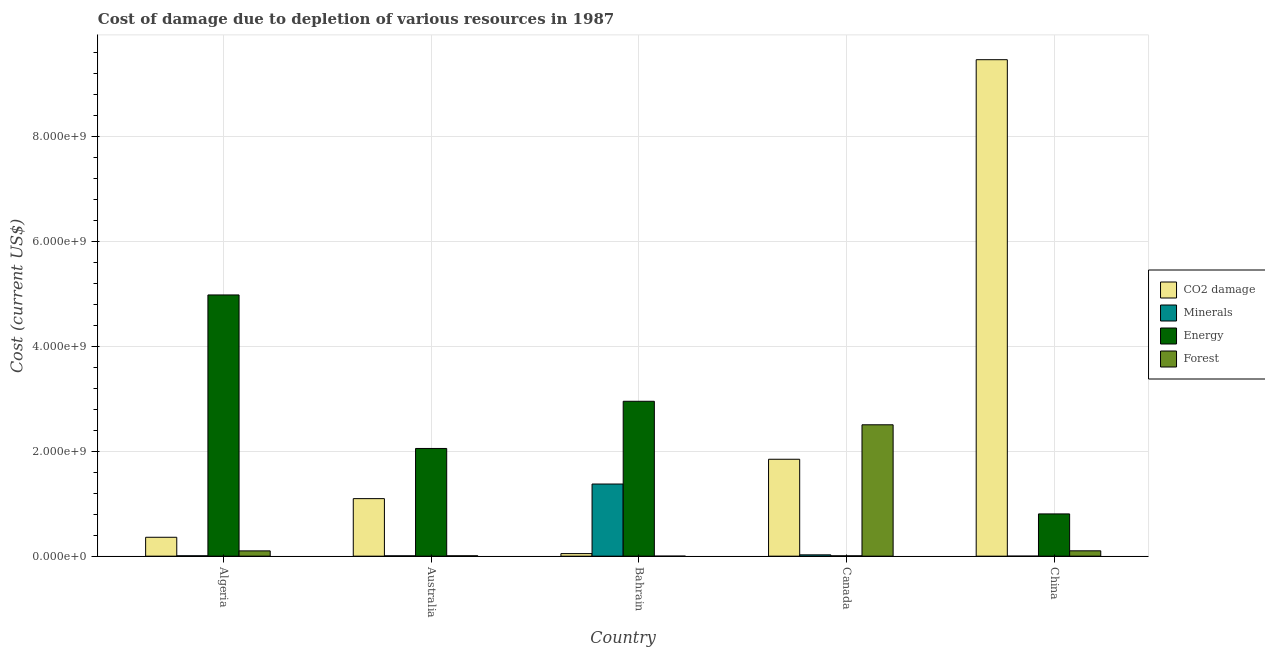Are the number of bars per tick equal to the number of legend labels?
Make the answer very short. Yes. How many bars are there on the 5th tick from the left?
Your answer should be very brief. 4. How many bars are there on the 1st tick from the right?
Give a very brief answer. 4. In how many cases, is the number of bars for a given country not equal to the number of legend labels?
Offer a very short reply. 0. What is the cost of damage due to depletion of coal in China?
Keep it short and to the point. 9.46e+09. Across all countries, what is the maximum cost of damage due to depletion of coal?
Your answer should be compact. 9.46e+09. Across all countries, what is the minimum cost of damage due to depletion of forests?
Ensure brevity in your answer.  1.92e+05. In which country was the cost of damage due to depletion of minerals minimum?
Your answer should be very brief. China. What is the total cost of damage due to depletion of minerals in the graph?
Provide a succinct answer. 1.41e+09. What is the difference between the cost of damage due to depletion of energy in Bahrain and that in Canada?
Provide a succinct answer. 2.94e+09. What is the difference between the cost of damage due to depletion of coal in Australia and the cost of damage due to depletion of forests in Canada?
Give a very brief answer. -1.41e+09. What is the average cost of damage due to depletion of energy per country?
Your answer should be compact. 2.16e+09. What is the difference between the cost of damage due to depletion of forests and cost of damage due to depletion of coal in Australia?
Your response must be concise. -1.09e+09. What is the ratio of the cost of damage due to depletion of minerals in Algeria to that in China?
Your response must be concise. 401.95. Is the difference between the cost of damage due to depletion of forests in Australia and Canada greater than the difference between the cost of damage due to depletion of coal in Australia and Canada?
Provide a short and direct response. No. What is the difference between the highest and the second highest cost of damage due to depletion of minerals?
Your response must be concise. 1.35e+09. What is the difference between the highest and the lowest cost of damage due to depletion of forests?
Make the answer very short. 2.50e+09. In how many countries, is the cost of damage due to depletion of energy greater than the average cost of damage due to depletion of energy taken over all countries?
Ensure brevity in your answer.  2. What does the 1st bar from the left in Australia represents?
Offer a very short reply. CO2 damage. What does the 2nd bar from the right in Canada represents?
Your response must be concise. Energy. How many bars are there?
Make the answer very short. 20. Are all the bars in the graph horizontal?
Ensure brevity in your answer.  No. How many countries are there in the graph?
Ensure brevity in your answer.  5. What is the difference between two consecutive major ticks on the Y-axis?
Offer a very short reply. 2.00e+09. How many legend labels are there?
Give a very brief answer. 4. What is the title of the graph?
Make the answer very short. Cost of damage due to depletion of various resources in 1987 . Does "Regional development banks" appear as one of the legend labels in the graph?
Your response must be concise. No. What is the label or title of the X-axis?
Offer a terse response. Country. What is the label or title of the Y-axis?
Provide a short and direct response. Cost (current US$). What is the Cost (current US$) of CO2 damage in Algeria?
Offer a terse response. 3.60e+08. What is the Cost (current US$) in Minerals in Algeria?
Provide a short and direct response. 7.39e+06. What is the Cost (current US$) in Energy in Algeria?
Your response must be concise. 4.97e+09. What is the Cost (current US$) in Forest in Algeria?
Offer a terse response. 1.01e+08. What is the Cost (current US$) in CO2 damage in Australia?
Make the answer very short. 1.10e+09. What is the Cost (current US$) in Minerals in Australia?
Provide a succinct answer. 6.31e+06. What is the Cost (current US$) of Energy in Australia?
Keep it short and to the point. 2.05e+09. What is the Cost (current US$) of Forest in Australia?
Offer a terse response. 7.12e+06. What is the Cost (current US$) in CO2 damage in Bahrain?
Keep it short and to the point. 4.89e+07. What is the Cost (current US$) of Minerals in Bahrain?
Give a very brief answer. 1.37e+09. What is the Cost (current US$) of Energy in Bahrain?
Your response must be concise. 2.95e+09. What is the Cost (current US$) in Forest in Bahrain?
Provide a succinct answer. 1.92e+05. What is the Cost (current US$) of CO2 damage in Canada?
Keep it short and to the point. 1.85e+09. What is the Cost (current US$) of Minerals in Canada?
Ensure brevity in your answer.  2.52e+07. What is the Cost (current US$) in Energy in Canada?
Your answer should be compact. 6.45e+06. What is the Cost (current US$) in Forest in Canada?
Make the answer very short. 2.50e+09. What is the Cost (current US$) in CO2 damage in China?
Offer a very short reply. 9.46e+09. What is the Cost (current US$) of Minerals in China?
Offer a very short reply. 1.84e+04. What is the Cost (current US$) in Energy in China?
Provide a succinct answer. 8.05e+08. What is the Cost (current US$) of Forest in China?
Give a very brief answer. 1.02e+08. Across all countries, what is the maximum Cost (current US$) of CO2 damage?
Make the answer very short. 9.46e+09. Across all countries, what is the maximum Cost (current US$) in Minerals?
Your answer should be compact. 1.37e+09. Across all countries, what is the maximum Cost (current US$) in Energy?
Ensure brevity in your answer.  4.97e+09. Across all countries, what is the maximum Cost (current US$) of Forest?
Offer a terse response. 2.50e+09. Across all countries, what is the minimum Cost (current US$) of CO2 damage?
Ensure brevity in your answer.  4.89e+07. Across all countries, what is the minimum Cost (current US$) of Minerals?
Your answer should be compact. 1.84e+04. Across all countries, what is the minimum Cost (current US$) in Energy?
Your response must be concise. 6.45e+06. Across all countries, what is the minimum Cost (current US$) in Forest?
Make the answer very short. 1.92e+05. What is the total Cost (current US$) in CO2 damage in the graph?
Make the answer very short. 1.28e+1. What is the total Cost (current US$) in Minerals in the graph?
Your response must be concise. 1.41e+09. What is the total Cost (current US$) of Energy in the graph?
Keep it short and to the point. 1.08e+1. What is the total Cost (current US$) in Forest in the graph?
Give a very brief answer. 2.71e+09. What is the difference between the Cost (current US$) in CO2 damage in Algeria and that in Australia?
Provide a short and direct response. -7.36e+08. What is the difference between the Cost (current US$) of Minerals in Algeria and that in Australia?
Your response must be concise. 1.08e+06. What is the difference between the Cost (current US$) of Energy in Algeria and that in Australia?
Offer a very short reply. 2.92e+09. What is the difference between the Cost (current US$) of Forest in Algeria and that in Australia?
Keep it short and to the point. 9.35e+07. What is the difference between the Cost (current US$) in CO2 damage in Algeria and that in Bahrain?
Make the answer very short. 3.11e+08. What is the difference between the Cost (current US$) of Minerals in Algeria and that in Bahrain?
Offer a terse response. -1.37e+09. What is the difference between the Cost (current US$) of Energy in Algeria and that in Bahrain?
Offer a terse response. 2.02e+09. What is the difference between the Cost (current US$) of Forest in Algeria and that in Bahrain?
Offer a terse response. 1.00e+08. What is the difference between the Cost (current US$) of CO2 damage in Algeria and that in Canada?
Offer a terse response. -1.49e+09. What is the difference between the Cost (current US$) in Minerals in Algeria and that in Canada?
Keep it short and to the point. -1.78e+07. What is the difference between the Cost (current US$) of Energy in Algeria and that in Canada?
Provide a short and direct response. 4.97e+09. What is the difference between the Cost (current US$) in Forest in Algeria and that in Canada?
Keep it short and to the point. -2.40e+09. What is the difference between the Cost (current US$) in CO2 damage in Algeria and that in China?
Provide a succinct answer. -9.10e+09. What is the difference between the Cost (current US$) of Minerals in Algeria and that in China?
Offer a terse response. 7.37e+06. What is the difference between the Cost (current US$) in Energy in Algeria and that in China?
Offer a terse response. 4.17e+09. What is the difference between the Cost (current US$) in Forest in Algeria and that in China?
Give a very brief answer. -1.20e+06. What is the difference between the Cost (current US$) in CO2 damage in Australia and that in Bahrain?
Provide a short and direct response. 1.05e+09. What is the difference between the Cost (current US$) in Minerals in Australia and that in Bahrain?
Your answer should be compact. -1.37e+09. What is the difference between the Cost (current US$) of Energy in Australia and that in Bahrain?
Your answer should be compact. -8.99e+08. What is the difference between the Cost (current US$) of Forest in Australia and that in Bahrain?
Your answer should be compact. 6.92e+06. What is the difference between the Cost (current US$) in CO2 damage in Australia and that in Canada?
Make the answer very short. -7.50e+08. What is the difference between the Cost (current US$) in Minerals in Australia and that in Canada?
Offer a terse response. -1.89e+07. What is the difference between the Cost (current US$) of Energy in Australia and that in Canada?
Your answer should be compact. 2.04e+09. What is the difference between the Cost (current US$) of Forest in Australia and that in Canada?
Ensure brevity in your answer.  -2.50e+09. What is the difference between the Cost (current US$) of CO2 damage in Australia and that in China?
Ensure brevity in your answer.  -8.36e+09. What is the difference between the Cost (current US$) of Minerals in Australia and that in China?
Your response must be concise. 6.29e+06. What is the difference between the Cost (current US$) in Energy in Australia and that in China?
Provide a succinct answer. 1.25e+09. What is the difference between the Cost (current US$) of Forest in Australia and that in China?
Give a very brief answer. -9.47e+07. What is the difference between the Cost (current US$) in CO2 damage in Bahrain and that in Canada?
Provide a succinct answer. -1.80e+09. What is the difference between the Cost (current US$) in Minerals in Bahrain and that in Canada?
Offer a terse response. 1.35e+09. What is the difference between the Cost (current US$) in Energy in Bahrain and that in Canada?
Give a very brief answer. 2.94e+09. What is the difference between the Cost (current US$) of Forest in Bahrain and that in Canada?
Make the answer very short. -2.50e+09. What is the difference between the Cost (current US$) of CO2 damage in Bahrain and that in China?
Offer a terse response. -9.41e+09. What is the difference between the Cost (current US$) in Minerals in Bahrain and that in China?
Your response must be concise. 1.37e+09. What is the difference between the Cost (current US$) of Energy in Bahrain and that in China?
Offer a terse response. 2.15e+09. What is the difference between the Cost (current US$) of Forest in Bahrain and that in China?
Provide a short and direct response. -1.02e+08. What is the difference between the Cost (current US$) of CO2 damage in Canada and that in China?
Your response must be concise. -7.61e+09. What is the difference between the Cost (current US$) in Minerals in Canada and that in China?
Keep it short and to the point. 2.51e+07. What is the difference between the Cost (current US$) of Energy in Canada and that in China?
Keep it short and to the point. -7.98e+08. What is the difference between the Cost (current US$) of Forest in Canada and that in China?
Keep it short and to the point. 2.40e+09. What is the difference between the Cost (current US$) of CO2 damage in Algeria and the Cost (current US$) of Minerals in Australia?
Provide a succinct answer. 3.54e+08. What is the difference between the Cost (current US$) of CO2 damage in Algeria and the Cost (current US$) of Energy in Australia?
Keep it short and to the point. -1.69e+09. What is the difference between the Cost (current US$) of CO2 damage in Algeria and the Cost (current US$) of Forest in Australia?
Offer a very short reply. 3.53e+08. What is the difference between the Cost (current US$) of Minerals in Algeria and the Cost (current US$) of Energy in Australia?
Give a very brief answer. -2.04e+09. What is the difference between the Cost (current US$) in Minerals in Algeria and the Cost (current US$) in Forest in Australia?
Keep it short and to the point. 2.70e+05. What is the difference between the Cost (current US$) of Energy in Algeria and the Cost (current US$) of Forest in Australia?
Your response must be concise. 4.97e+09. What is the difference between the Cost (current US$) of CO2 damage in Algeria and the Cost (current US$) of Minerals in Bahrain?
Provide a succinct answer. -1.01e+09. What is the difference between the Cost (current US$) of CO2 damage in Algeria and the Cost (current US$) of Energy in Bahrain?
Keep it short and to the point. -2.59e+09. What is the difference between the Cost (current US$) in CO2 damage in Algeria and the Cost (current US$) in Forest in Bahrain?
Your answer should be compact. 3.60e+08. What is the difference between the Cost (current US$) of Minerals in Algeria and the Cost (current US$) of Energy in Bahrain?
Offer a terse response. -2.94e+09. What is the difference between the Cost (current US$) of Minerals in Algeria and the Cost (current US$) of Forest in Bahrain?
Offer a terse response. 7.19e+06. What is the difference between the Cost (current US$) of Energy in Algeria and the Cost (current US$) of Forest in Bahrain?
Your response must be concise. 4.97e+09. What is the difference between the Cost (current US$) in CO2 damage in Algeria and the Cost (current US$) in Minerals in Canada?
Offer a terse response. 3.35e+08. What is the difference between the Cost (current US$) in CO2 damage in Algeria and the Cost (current US$) in Energy in Canada?
Give a very brief answer. 3.54e+08. What is the difference between the Cost (current US$) of CO2 damage in Algeria and the Cost (current US$) of Forest in Canada?
Your answer should be compact. -2.14e+09. What is the difference between the Cost (current US$) of Minerals in Algeria and the Cost (current US$) of Energy in Canada?
Your answer should be compact. 9.36e+05. What is the difference between the Cost (current US$) in Minerals in Algeria and the Cost (current US$) in Forest in Canada?
Offer a very short reply. -2.49e+09. What is the difference between the Cost (current US$) of Energy in Algeria and the Cost (current US$) of Forest in Canada?
Offer a terse response. 2.47e+09. What is the difference between the Cost (current US$) of CO2 damage in Algeria and the Cost (current US$) of Minerals in China?
Provide a short and direct response. 3.60e+08. What is the difference between the Cost (current US$) of CO2 damage in Algeria and the Cost (current US$) of Energy in China?
Offer a very short reply. -4.45e+08. What is the difference between the Cost (current US$) in CO2 damage in Algeria and the Cost (current US$) in Forest in China?
Make the answer very short. 2.58e+08. What is the difference between the Cost (current US$) of Minerals in Algeria and the Cost (current US$) of Energy in China?
Offer a very short reply. -7.97e+08. What is the difference between the Cost (current US$) of Minerals in Algeria and the Cost (current US$) of Forest in China?
Make the answer very short. -9.45e+07. What is the difference between the Cost (current US$) of Energy in Algeria and the Cost (current US$) of Forest in China?
Your answer should be very brief. 4.87e+09. What is the difference between the Cost (current US$) in CO2 damage in Australia and the Cost (current US$) in Minerals in Bahrain?
Keep it short and to the point. -2.78e+08. What is the difference between the Cost (current US$) of CO2 damage in Australia and the Cost (current US$) of Energy in Bahrain?
Your response must be concise. -1.85e+09. What is the difference between the Cost (current US$) in CO2 damage in Australia and the Cost (current US$) in Forest in Bahrain?
Provide a succinct answer. 1.10e+09. What is the difference between the Cost (current US$) in Minerals in Australia and the Cost (current US$) in Energy in Bahrain?
Provide a succinct answer. -2.94e+09. What is the difference between the Cost (current US$) in Minerals in Australia and the Cost (current US$) in Forest in Bahrain?
Offer a very short reply. 6.11e+06. What is the difference between the Cost (current US$) of Energy in Australia and the Cost (current US$) of Forest in Bahrain?
Provide a succinct answer. 2.05e+09. What is the difference between the Cost (current US$) of CO2 damage in Australia and the Cost (current US$) of Minerals in Canada?
Provide a succinct answer. 1.07e+09. What is the difference between the Cost (current US$) in CO2 damage in Australia and the Cost (current US$) in Energy in Canada?
Provide a succinct answer. 1.09e+09. What is the difference between the Cost (current US$) in CO2 damage in Australia and the Cost (current US$) in Forest in Canada?
Your answer should be compact. -1.41e+09. What is the difference between the Cost (current US$) of Minerals in Australia and the Cost (current US$) of Energy in Canada?
Your answer should be compact. -1.43e+05. What is the difference between the Cost (current US$) in Minerals in Australia and the Cost (current US$) in Forest in Canada?
Offer a terse response. -2.50e+09. What is the difference between the Cost (current US$) in Energy in Australia and the Cost (current US$) in Forest in Canada?
Offer a very short reply. -4.51e+08. What is the difference between the Cost (current US$) of CO2 damage in Australia and the Cost (current US$) of Minerals in China?
Give a very brief answer. 1.10e+09. What is the difference between the Cost (current US$) of CO2 damage in Australia and the Cost (current US$) of Energy in China?
Your answer should be very brief. 2.91e+08. What is the difference between the Cost (current US$) in CO2 damage in Australia and the Cost (current US$) in Forest in China?
Keep it short and to the point. 9.94e+08. What is the difference between the Cost (current US$) of Minerals in Australia and the Cost (current US$) of Energy in China?
Provide a succinct answer. -7.98e+08. What is the difference between the Cost (current US$) in Minerals in Australia and the Cost (current US$) in Forest in China?
Ensure brevity in your answer.  -9.56e+07. What is the difference between the Cost (current US$) of Energy in Australia and the Cost (current US$) of Forest in China?
Keep it short and to the point. 1.95e+09. What is the difference between the Cost (current US$) in CO2 damage in Bahrain and the Cost (current US$) in Minerals in Canada?
Provide a short and direct response. 2.37e+07. What is the difference between the Cost (current US$) in CO2 damage in Bahrain and the Cost (current US$) in Energy in Canada?
Your response must be concise. 4.25e+07. What is the difference between the Cost (current US$) in CO2 damage in Bahrain and the Cost (current US$) in Forest in Canada?
Ensure brevity in your answer.  -2.45e+09. What is the difference between the Cost (current US$) of Minerals in Bahrain and the Cost (current US$) of Energy in Canada?
Your response must be concise. 1.37e+09. What is the difference between the Cost (current US$) in Minerals in Bahrain and the Cost (current US$) in Forest in Canada?
Offer a very short reply. -1.13e+09. What is the difference between the Cost (current US$) of Energy in Bahrain and the Cost (current US$) of Forest in Canada?
Your response must be concise. 4.48e+08. What is the difference between the Cost (current US$) in CO2 damage in Bahrain and the Cost (current US$) in Minerals in China?
Offer a very short reply. 4.89e+07. What is the difference between the Cost (current US$) of CO2 damage in Bahrain and the Cost (current US$) of Energy in China?
Your answer should be compact. -7.56e+08. What is the difference between the Cost (current US$) of CO2 damage in Bahrain and the Cost (current US$) of Forest in China?
Your answer should be very brief. -5.29e+07. What is the difference between the Cost (current US$) of Minerals in Bahrain and the Cost (current US$) of Energy in China?
Ensure brevity in your answer.  5.69e+08. What is the difference between the Cost (current US$) of Minerals in Bahrain and the Cost (current US$) of Forest in China?
Your answer should be compact. 1.27e+09. What is the difference between the Cost (current US$) of Energy in Bahrain and the Cost (current US$) of Forest in China?
Offer a terse response. 2.85e+09. What is the difference between the Cost (current US$) in CO2 damage in Canada and the Cost (current US$) in Minerals in China?
Your answer should be compact. 1.85e+09. What is the difference between the Cost (current US$) in CO2 damage in Canada and the Cost (current US$) in Energy in China?
Keep it short and to the point. 1.04e+09. What is the difference between the Cost (current US$) in CO2 damage in Canada and the Cost (current US$) in Forest in China?
Offer a terse response. 1.74e+09. What is the difference between the Cost (current US$) in Minerals in Canada and the Cost (current US$) in Energy in China?
Give a very brief answer. -7.80e+08. What is the difference between the Cost (current US$) of Minerals in Canada and the Cost (current US$) of Forest in China?
Your response must be concise. -7.67e+07. What is the difference between the Cost (current US$) of Energy in Canada and the Cost (current US$) of Forest in China?
Provide a short and direct response. -9.54e+07. What is the average Cost (current US$) of CO2 damage per country?
Ensure brevity in your answer.  2.56e+09. What is the average Cost (current US$) in Minerals per country?
Provide a short and direct response. 2.83e+08. What is the average Cost (current US$) of Energy per country?
Give a very brief answer. 2.16e+09. What is the average Cost (current US$) in Forest per country?
Your answer should be compact. 5.42e+08. What is the difference between the Cost (current US$) of CO2 damage and Cost (current US$) of Minerals in Algeria?
Offer a very short reply. 3.53e+08. What is the difference between the Cost (current US$) in CO2 damage and Cost (current US$) in Energy in Algeria?
Your answer should be very brief. -4.62e+09. What is the difference between the Cost (current US$) of CO2 damage and Cost (current US$) of Forest in Algeria?
Offer a very short reply. 2.59e+08. What is the difference between the Cost (current US$) in Minerals and Cost (current US$) in Energy in Algeria?
Your answer should be very brief. -4.97e+09. What is the difference between the Cost (current US$) of Minerals and Cost (current US$) of Forest in Algeria?
Keep it short and to the point. -9.33e+07. What is the difference between the Cost (current US$) in Energy and Cost (current US$) in Forest in Algeria?
Give a very brief answer. 4.87e+09. What is the difference between the Cost (current US$) in CO2 damage and Cost (current US$) in Minerals in Australia?
Your response must be concise. 1.09e+09. What is the difference between the Cost (current US$) of CO2 damage and Cost (current US$) of Energy in Australia?
Your answer should be very brief. -9.56e+08. What is the difference between the Cost (current US$) of CO2 damage and Cost (current US$) of Forest in Australia?
Your response must be concise. 1.09e+09. What is the difference between the Cost (current US$) in Minerals and Cost (current US$) in Energy in Australia?
Your response must be concise. -2.05e+09. What is the difference between the Cost (current US$) in Minerals and Cost (current US$) in Forest in Australia?
Provide a short and direct response. -8.10e+05. What is the difference between the Cost (current US$) of Energy and Cost (current US$) of Forest in Australia?
Make the answer very short. 2.04e+09. What is the difference between the Cost (current US$) in CO2 damage and Cost (current US$) in Minerals in Bahrain?
Provide a succinct answer. -1.33e+09. What is the difference between the Cost (current US$) of CO2 damage and Cost (current US$) of Energy in Bahrain?
Provide a short and direct response. -2.90e+09. What is the difference between the Cost (current US$) in CO2 damage and Cost (current US$) in Forest in Bahrain?
Your answer should be compact. 4.87e+07. What is the difference between the Cost (current US$) in Minerals and Cost (current US$) in Energy in Bahrain?
Provide a short and direct response. -1.58e+09. What is the difference between the Cost (current US$) of Minerals and Cost (current US$) of Forest in Bahrain?
Your answer should be compact. 1.37e+09. What is the difference between the Cost (current US$) in Energy and Cost (current US$) in Forest in Bahrain?
Make the answer very short. 2.95e+09. What is the difference between the Cost (current US$) in CO2 damage and Cost (current US$) in Minerals in Canada?
Offer a very short reply. 1.82e+09. What is the difference between the Cost (current US$) in CO2 damage and Cost (current US$) in Energy in Canada?
Ensure brevity in your answer.  1.84e+09. What is the difference between the Cost (current US$) of CO2 damage and Cost (current US$) of Forest in Canada?
Provide a succinct answer. -6.57e+08. What is the difference between the Cost (current US$) of Minerals and Cost (current US$) of Energy in Canada?
Give a very brief answer. 1.87e+07. What is the difference between the Cost (current US$) in Minerals and Cost (current US$) in Forest in Canada?
Keep it short and to the point. -2.48e+09. What is the difference between the Cost (current US$) in Energy and Cost (current US$) in Forest in Canada?
Provide a short and direct response. -2.50e+09. What is the difference between the Cost (current US$) of CO2 damage and Cost (current US$) of Minerals in China?
Keep it short and to the point. 9.46e+09. What is the difference between the Cost (current US$) in CO2 damage and Cost (current US$) in Energy in China?
Keep it short and to the point. 8.65e+09. What is the difference between the Cost (current US$) in CO2 damage and Cost (current US$) in Forest in China?
Offer a terse response. 9.35e+09. What is the difference between the Cost (current US$) of Minerals and Cost (current US$) of Energy in China?
Keep it short and to the point. -8.05e+08. What is the difference between the Cost (current US$) of Minerals and Cost (current US$) of Forest in China?
Keep it short and to the point. -1.02e+08. What is the difference between the Cost (current US$) in Energy and Cost (current US$) in Forest in China?
Provide a succinct answer. 7.03e+08. What is the ratio of the Cost (current US$) in CO2 damage in Algeria to that in Australia?
Provide a succinct answer. 0.33. What is the ratio of the Cost (current US$) of Minerals in Algeria to that in Australia?
Provide a short and direct response. 1.17. What is the ratio of the Cost (current US$) in Energy in Algeria to that in Australia?
Make the answer very short. 2.43. What is the ratio of the Cost (current US$) in Forest in Algeria to that in Australia?
Make the answer very short. 14.14. What is the ratio of the Cost (current US$) of CO2 damage in Algeria to that in Bahrain?
Your response must be concise. 7.36. What is the ratio of the Cost (current US$) in Minerals in Algeria to that in Bahrain?
Your response must be concise. 0.01. What is the ratio of the Cost (current US$) of Energy in Algeria to that in Bahrain?
Keep it short and to the point. 1.69. What is the ratio of the Cost (current US$) in Forest in Algeria to that in Bahrain?
Keep it short and to the point. 524.68. What is the ratio of the Cost (current US$) of CO2 damage in Algeria to that in Canada?
Offer a very short reply. 0.2. What is the ratio of the Cost (current US$) of Minerals in Algeria to that in Canada?
Make the answer very short. 0.29. What is the ratio of the Cost (current US$) in Energy in Algeria to that in Canada?
Make the answer very short. 771.37. What is the ratio of the Cost (current US$) of Forest in Algeria to that in Canada?
Give a very brief answer. 0.04. What is the ratio of the Cost (current US$) in CO2 damage in Algeria to that in China?
Make the answer very short. 0.04. What is the ratio of the Cost (current US$) in Minerals in Algeria to that in China?
Provide a short and direct response. 401.95. What is the ratio of the Cost (current US$) of Energy in Algeria to that in China?
Your response must be concise. 6.18. What is the ratio of the Cost (current US$) of Forest in Algeria to that in China?
Provide a short and direct response. 0.99. What is the ratio of the Cost (current US$) of CO2 damage in Australia to that in Bahrain?
Make the answer very short. 22.41. What is the ratio of the Cost (current US$) in Minerals in Australia to that in Bahrain?
Make the answer very short. 0. What is the ratio of the Cost (current US$) in Energy in Australia to that in Bahrain?
Your answer should be compact. 0.7. What is the ratio of the Cost (current US$) in Forest in Australia to that in Bahrain?
Provide a succinct answer. 37.09. What is the ratio of the Cost (current US$) of CO2 damage in Australia to that in Canada?
Ensure brevity in your answer.  0.59. What is the ratio of the Cost (current US$) in Minerals in Australia to that in Canada?
Your answer should be compact. 0.25. What is the ratio of the Cost (current US$) of Energy in Australia to that in Canada?
Offer a terse response. 318.07. What is the ratio of the Cost (current US$) in Forest in Australia to that in Canada?
Your response must be concise. 0. What is the ratio of the Cost (current US$) in CO2 damage in Australia to that in China?
Offer a very short reply. 0.12. What is the ratio of the Cost (current US$) of Minerals in Australia to that in China?
Your response must be concise. 343.2. What is the ratio of the Cost (current US$) in Energy in Australia to that in China?
Your answer should be very brief. 2.55. What is the ratio of the Cost (current US$) of Forest in Australia to that in China?
Provide a succinct answer. 0.07. What is the ratio of the Cost (current US$) of CO2 damage in Bahrain to that in Canada?
Provide a short and direct response. 0.03. What is the ratio of the Cost (current US$) of Minerals in Bahrain to that in Canada?
Ensure brevity in your answer.  54.61. What is the ratio of the Cost (current US$) of Energy in Bahrain to that in Canada?
Give a very brief answer. 457.42. What is the ratio of the Cost (current US$) in Forest in Bahrain to that in Canada?
Provide a short and direct response. 0. What is the ratio of the Cost (current US$) of CO2 damage in Bahrain to that in China?
Your response must be concise. 0.01. What is the ratio of the Cost (current US$) in Minerals in Bahrain to that in China?
Give a very brief answer. 7.48e+04. What is the ratio of the Cost (current US$) in Energy in Bahrain to that in China?
Ensure brevity in your answer.  3.67. What is the ratio of the Cost (current US$) of Forest in Bahrain to that in China?
Make the answer very short. 0. What is the ratio of the Cost (current US$) in CO2 damage in Canada to that in China?
Offer a terse response. 0.2. What is the ratio of the Cost (current US$) of Minerals in Canada to that in China?
Offer a terse response. 1369.24. What is the ratio of the Cost (current US$) of Energy in Canada to that in China?
Give a very brief answer. 0.01. What is the ratio of the Cost (current US$) of Forest in Canada to that in China?
Offer a very short reply. 24.57. What is the difference between the highest and the second highest Cost (current US$) of CO2 damage?
Your answer should be compact. 7.61e+09. What is the difference between the highest and the second highest Cost (current US$) of Minerals?
Your response must be concise. 1.35e+09. What is the difference between the highest and the second highest Cost (current US$) in Energy?
Ensure brevity in your answer.  2.02e+09. What is the difference between the highest and the second highest Cost (current US$) of Forest?
Your answer should be very brief. 2.40e+09. What is the difference between the highest and the lowest Cost (current US$) of CO2 damage?
Make the answer very short. 9.41e+09. What is the difference between the highest and the lowest Cost (current US$) of Minerals?
Provide a succinct answer. 1.37e+09. What is the difference between the highest and the lowest Cost (current US$) of Energy?
Your response must be concise. 4.97e+09. What is the difference between the highest and the lowest Cost (current US$) in Forest?
Make the answer very short. 2.50e+09. 